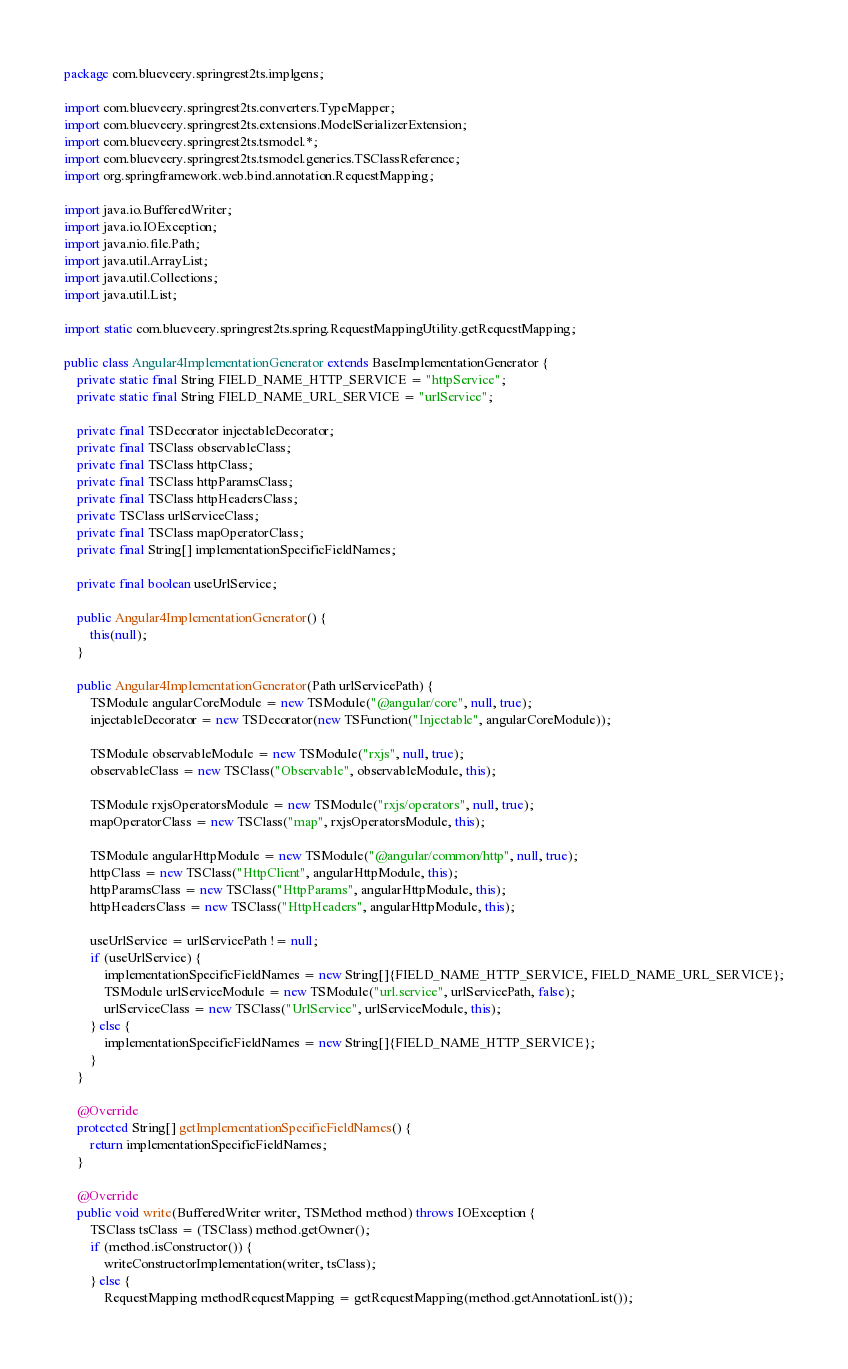Convert code to text. <code><loc_0><loc_0><loc_500><loc_500><_Java_>package com.blueveery.springrest2ts.implgens;

import com.blueveery.springrest2ts.converters.TypeMapper;
import com.blueveery.springrest2ts.extensions.ModelSerializerExtension;
import com.blueveery.springrest2ts.tsmodel.*;
import com.blueveery.springrest2ts.tsmodel.generics.TSClassReference;
import org.springframework.web.bind.annotation.RequestMapping;

import java.io.BufferedWriter;
import java.io.IOException;
import java.nio.file.Path;
import java.util.ArrayList;
import java.util.Collections;
import java.util.List;

import static com.blueveery.springrest2ts.spring.RequestMappingUtility.getRequestMapping;

public class Angular4ImplementationGenerator extends BaseImplementationGenerator {
    private static final String FIELD_NAME_HTTP_SERVICE = "httpService";
    private static final String FIELD_NAME_URL_SERVICE = "urlService";

    private final TSDecorator injectableDecorator;
    private final TSClass observableClass;
    private final TSClass httpClass;
    private final TSClass httpParamsClass;
    private final TSClass httpHeadersClass;
    private TSClass urlServiceClass;
    private final TSClass mapOperatorClass;
    private final String[] implementationSpecificFieldNames;

    private final boolean useUrlService;

    public Angular4ImplementationGenerator() {
        this(null);
    }

    public Angular4ImplementationGenerator(Path urlServicePath) {
        TSModule angularCoreModule = new TSModule("@angular/core", null, true);
        injectableDecorator = new TSDecorator(new TSFunction("Injectable", angularCoreModule));

        TSModule observableModule = new TSModule("rxjs", null, true);
        observableClass = new TSClass("Observable", observableModule, this);

        TSModule rxjsOperatorsModule = new TSModule("rxjs/operators", null, true);
        mapOperatorClass = new TSClass("map", rxjsOperatorsModule, this);

        TSModule angularHttpModule = new TSModule("@angular/common/http", null, true);
        httpClass = new TSClass("HttpClient", angularHttpModule, this);
        httpParamsClass = new TSClass("HttpParams", angularHttpModule, this);
        httpHeadersClass = new TSClass("HttpHeaders", angularHttpModule, this);

        useUrlService = urlServicePath != null;
        if (useUrlService) {
            implementationSpecificFieldNames = new String[]{FIELD_NAME_HTTP_SERVICE, FIELD_NAME_URL_SERVICE};
            TSModule urlServiceModule = new TSModule("url.service", urlServicePath, false);
            urlServiceClass = new TSClass("UrlService", urlServiceModule, this);
        } else {
            implementationSpecificFieldNames = new String[]{FIELD_NAME_HTTP_SERVICE};
        }
    }

    @Override
    protected String[] getImplementationSpecificFieldNames() {
        return implementationSpecificFieldNames;
    }

    @Override
    public void write(BufferedWriter writer, TSMethod method) throws IOException {
        TSClass tsClass = (TSClass) method.getOwner();
        if (method.isConstructor()) {
            writeConstructorImplementation(writer, tsClass);
        } else {
            RequestMapping methodRequestMapping = getRequestMapping(method.getAnnotationList());</code> 